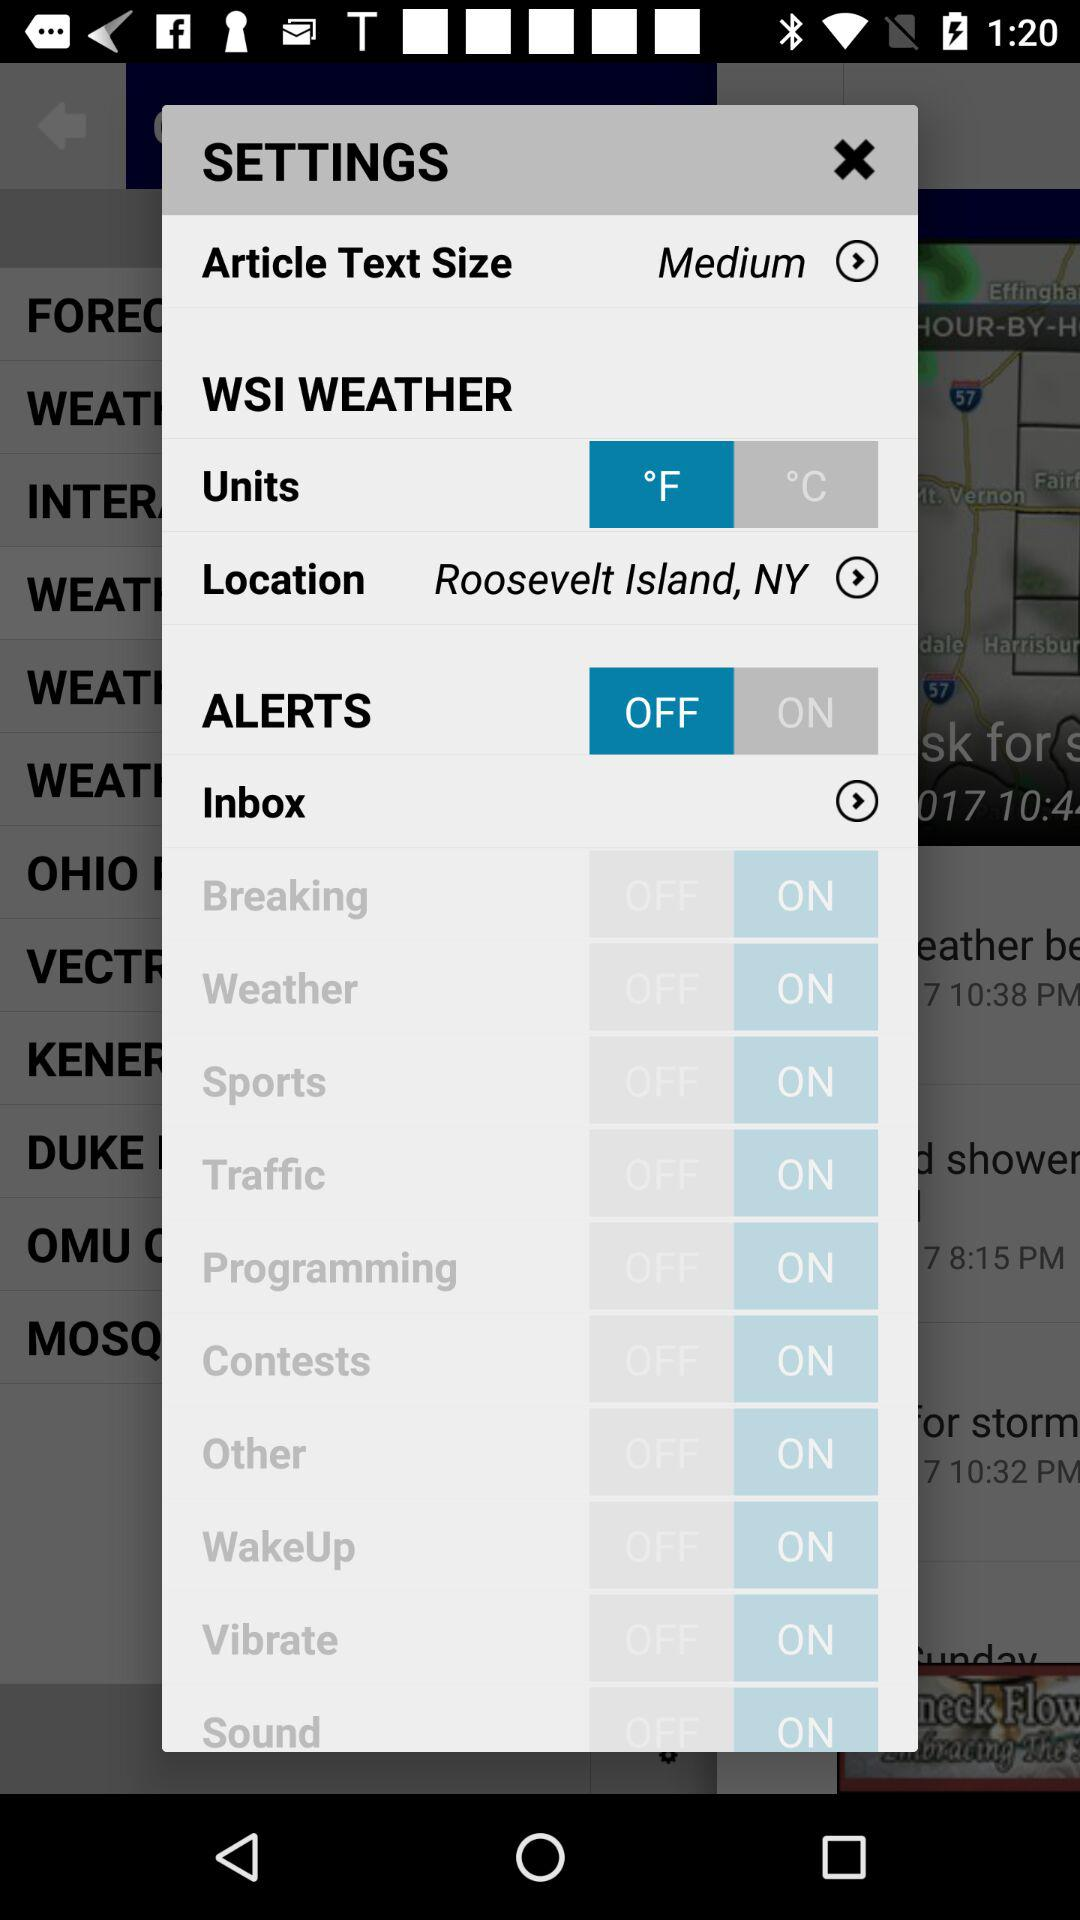What's the location shown on the screen? The location is Roosevelt Island, NY. 